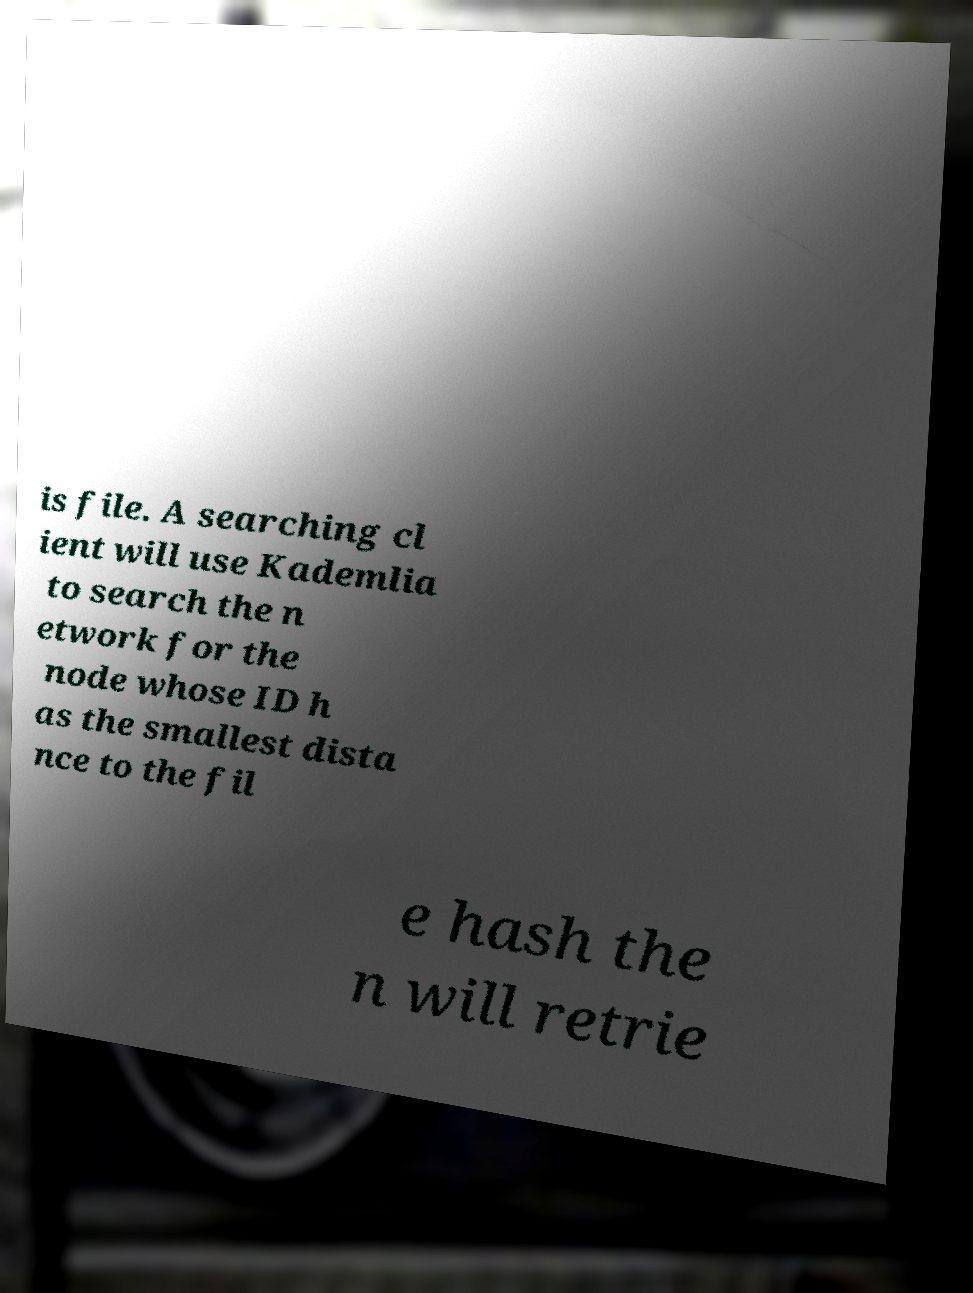Please read and relay the text visible in this image. What does it say? is file. A searching cl ient will use Kademlia to search the n etwork for the node whose ID h as the smallest dista nce to the fil e hash the n will retrie 